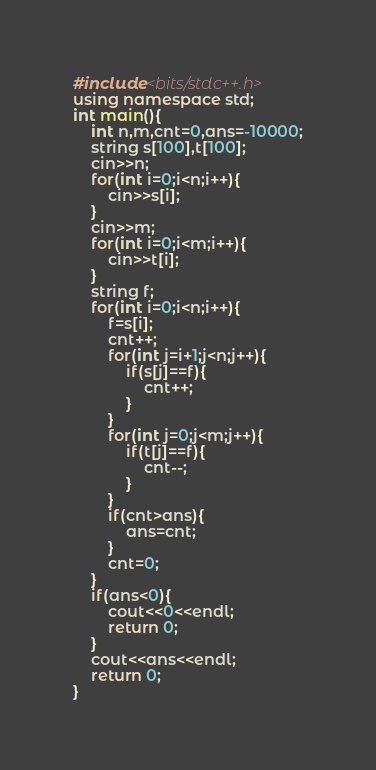Convert code to text. <code><loc_0><loc_0><loc_500><loc_500><_C++_>#include<bits/stdc++.h>
using namespace std;
int main(){
	int n,m,cnt=0,ans=-10000;
	string s[100],t[100];
	cin>>n;
	for(int i=0;i<n;i++){
		cin>>s[i];
	}
	cin>>m;
	for(int i=0;i<m;i++){
		cin>>t[i];
	}
	string f;
	for(int i=0;i<n;i++){
		f=s[i];
		cnt++;
		for(int j=i+1;j<n;j++){
			if(s[j]==f){
				cnt++;
			}
		}
		for(int j=0;j<m;j++){
			if(t[j]==f){
				cnt--;
			}
		}
		if(cnt>ans){
			ans=cnt;
		}
		cnt=0;
	}
	if(ans<0){
		cout<<0<<endl;
		return 0;
	}
	cout<<ans<<endl;
	return 0;
}
</code> 